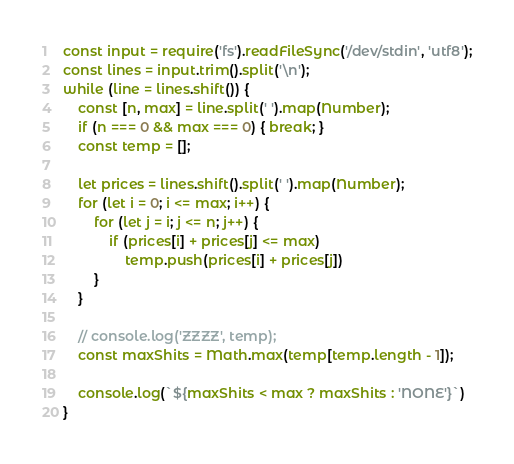Convert code to text. <code><loc_0><loc_0><loc_500><loc_500><_JavaScript_>const input = require('fs').readFileSync('/dev/stdin', 'utf8');
const lines = input.trim().split('\n');
while (line = lines.shift()) {
	const [n, max] = line.split(' ').map(Number);
	if (n === 0 && max === 0) { break; }
	const temp = [];

	let prices = lines.shift().split(' ').map(Number);
	for (let i = 0; i <= max; i++) {
		for (let j = i; j <= n; j++) {
			if (prices[i] + prices[j] <= max)
				temp.push(prices[i] + prices[j])
		}
	}

	// console.log('ZZZZ', temp);
	const maxShits = Math.max(temp[temp.length - 1]);

	console.log(`${maxShits < max ? maxShits : 'NONE'}`)
} 

</code> 